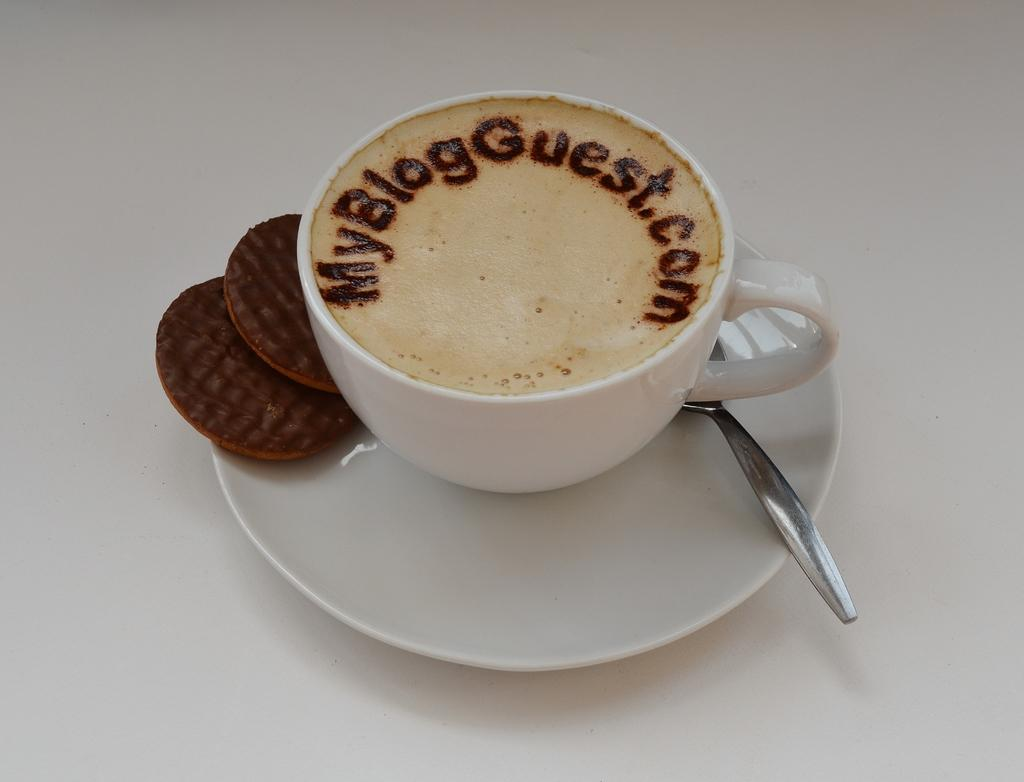What is one of the objects visible in the image? There is a cup in the image. What other items can be seen with the cup? There are biscuits and a spoon in the image. Can you describe the spoon's location in the image? The spoon is on a white color saucer. What is the color of the surface on which the objects are placed? The objects are on a white color surface. What type of sack is being used as a makeshift hospital bed in the image? There is no sack or hospital bed present in the image; it features a cup, biscuits, and a spoon on a white surface. 